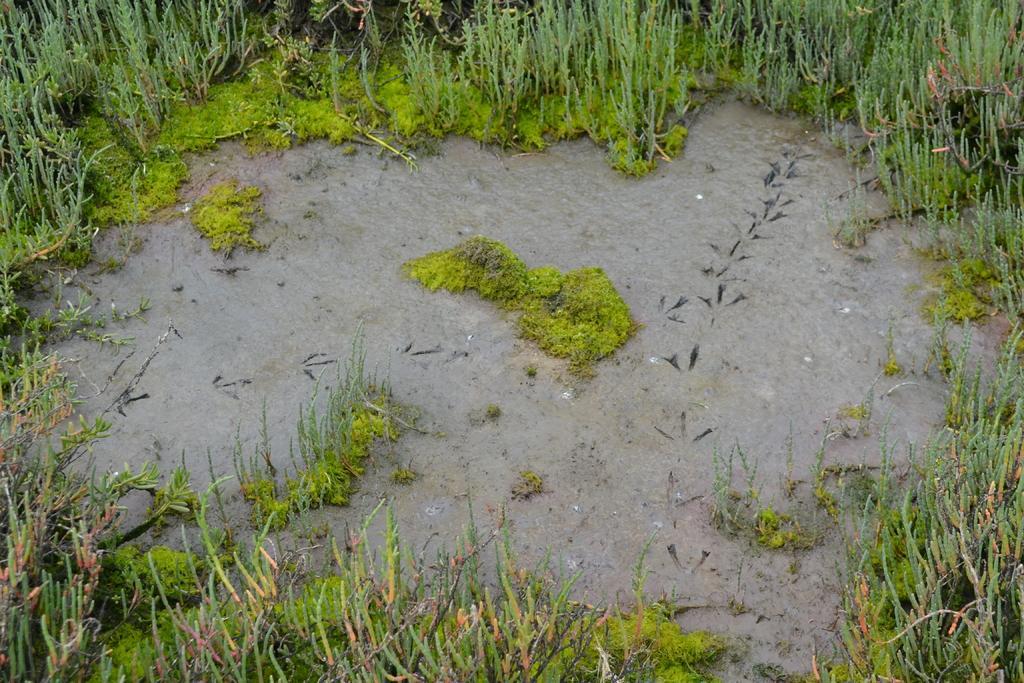Can you describe this image briefly? In this image we can see some water on the ground, some small plants and green grass on the ground. 